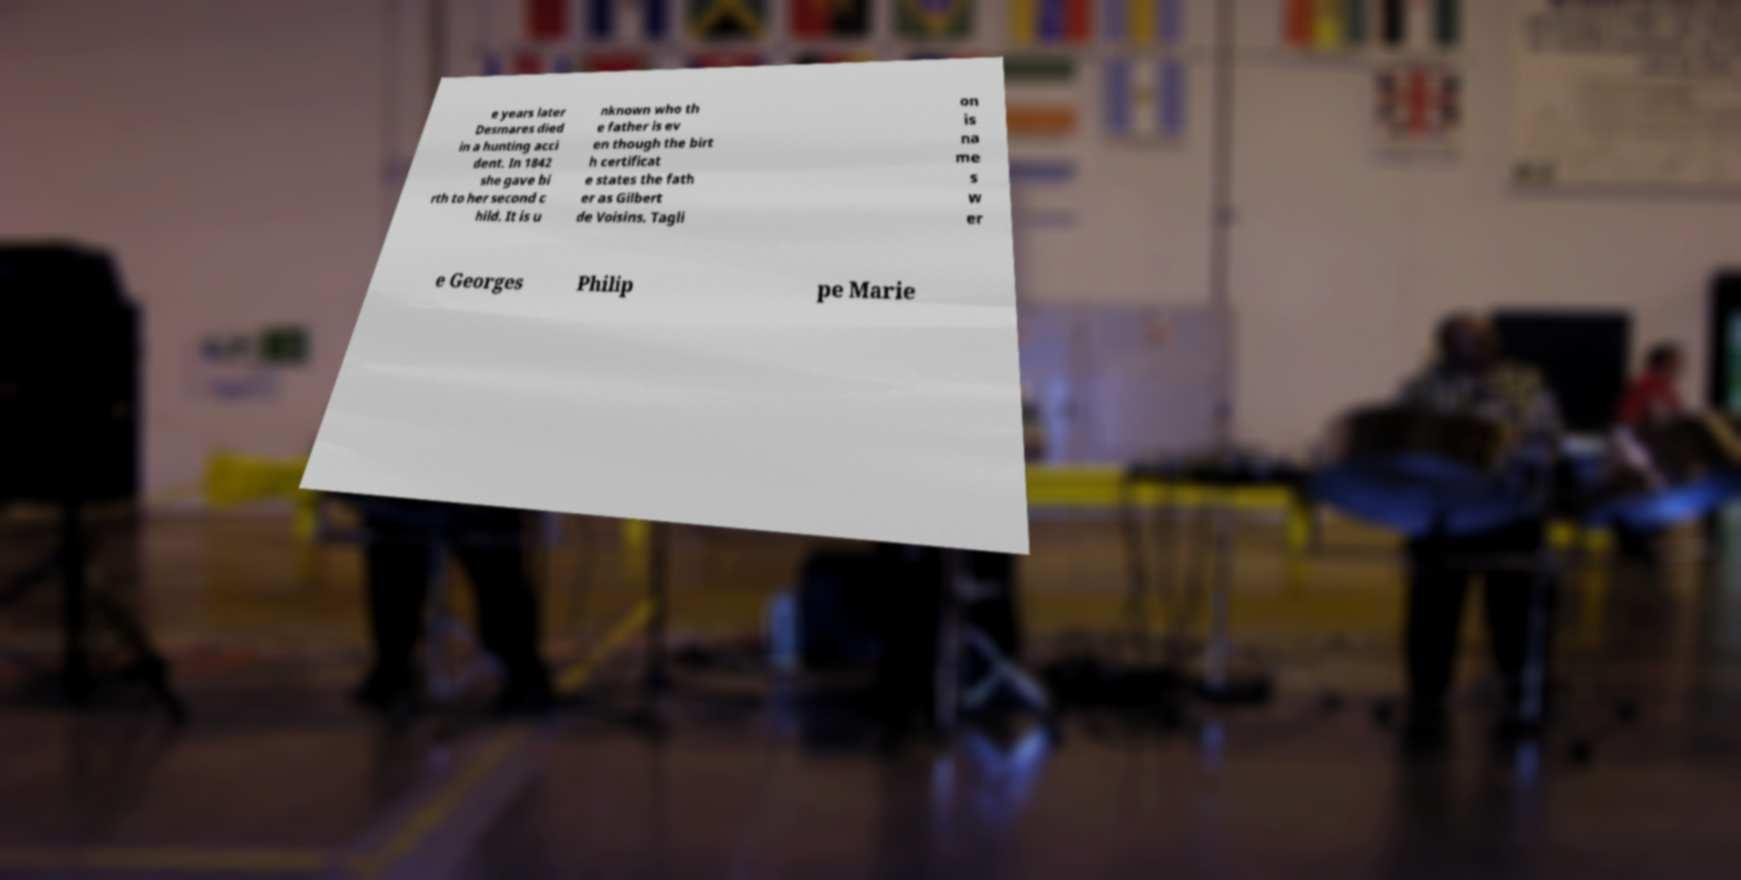Could you assist in decoding the text presented in this image and type it out clearly? e years later Desmares died in a hunting acci dent. In 1842 she gave bi rth to her second c hild. It is u nknown who th e father is ev en though the birt h certificat e states the fath er as Gilbert de Voisins. Tagli on is na me s w er e Georges Philip pe Marie 